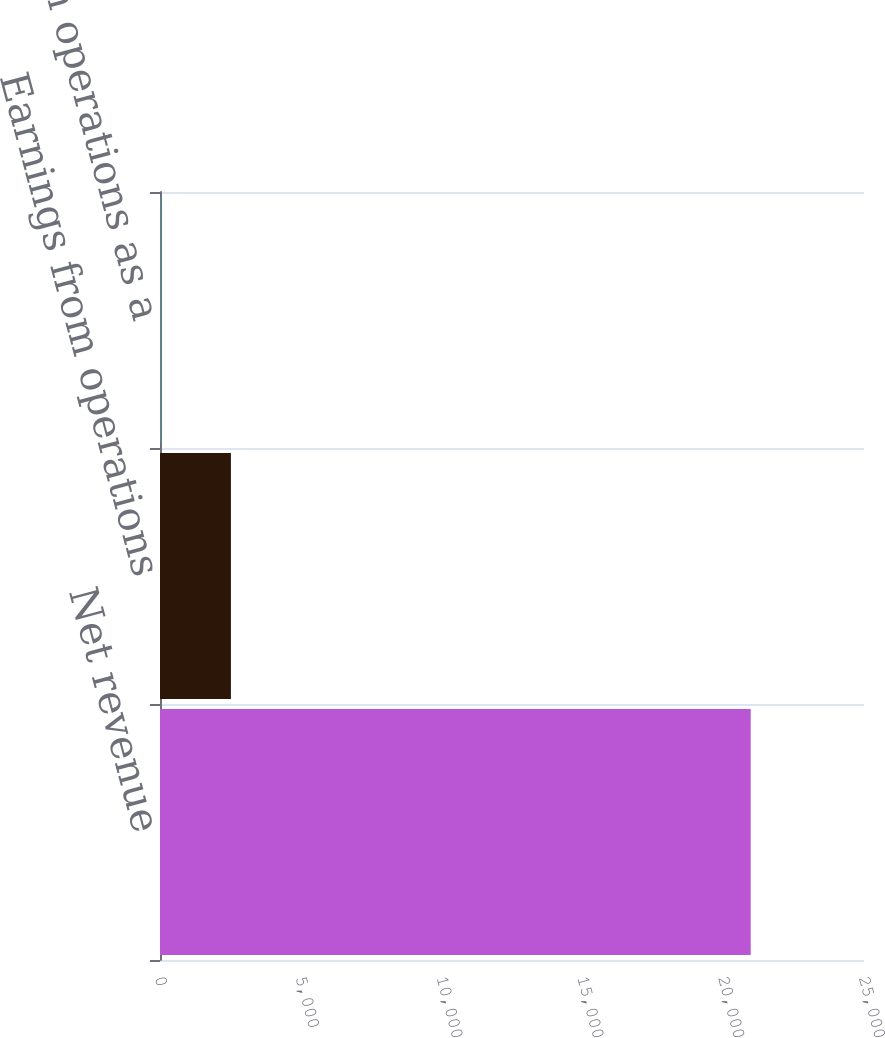<chart> <loc_0><loc_0><loc_500><loc_500><bar_chart><fcel>Net revenue<fcel>Earnings from operations<fcel>Earnings from operations as a<nl><fcel>20977<fcel>2518<fcel>12<nl></chart> 